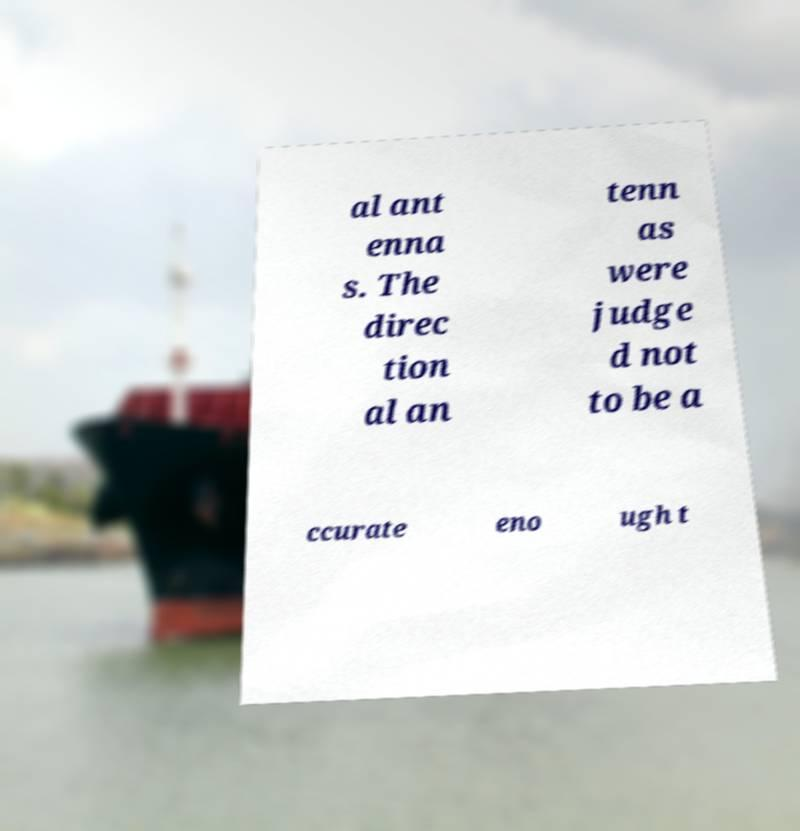Could you assist in decoding the text presented in this image and type it out clearly? al ant enna s. The direc tion al an tenn as were judge d not to be a ccurate eno ugh t 